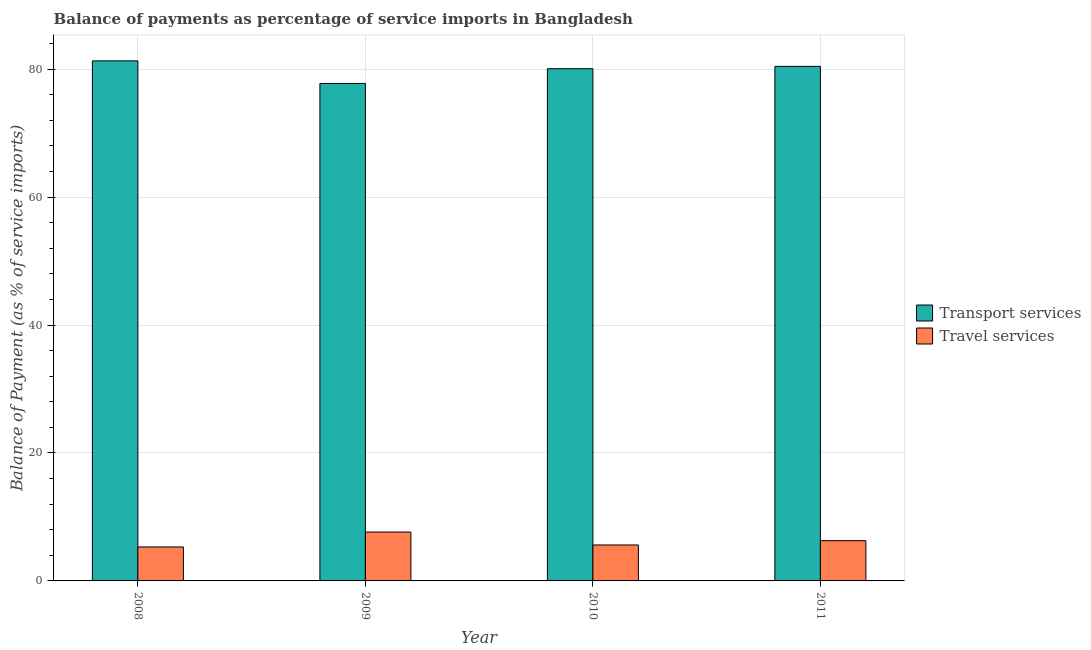How many groups of bars are there?
Your answer should be very brief. 4. Are the number of bars on each tick of the X-axis equal?
Offer a terse response. Yes. How many bars are there on the 2nd tick from the left?
Your answer should be compact. 2. In how many cases, is the number of bars for a given year not equal to the number of legend labels?
Offer a terse response. 0. What is the balance of payments of transport services in 2011?
Offer a very short reply. 80.43. Across all years, what is the maximum balance of payments of transport services?
Ensure brevity in your answer.  81.29. Across all years, what is the minimum balance of payments of travel services?
Offer a very short reply. 5.31. What is the total balance of payments of travel services in the graph?
Offer a very short reply. 24.86. What is the difference between the balance of payments of travel services in 2009 and that in 2010?
Keep it short and to the point. 2.02. What is the difference between the balance of payments of travel services in 2008 and the balance of payments of transport services in 2010?
Provide a short and direct response. -0.31. What is the average balance of payments of travel services per year?
Your answer should be very brief. 6.22. In how many years, is the balance of payments of transport services greater than 48 %?
Give a very brief answer. 4. What is the ratio of the balance of payments of transport services in 2008 to that in 2011?
Your response must be concise. 1.01. Is the balance of payments of transport services in 2010 less than that in 2011?
Provide a succinct answer. Yes. Is the difference between the balance of payments of transport services in 2008 and 2009 greater than the difference between the balance of payments of travel services in 2008 and 2009?
Ensure brevity in your answer.  No. What is the difference between the highest and the second highest balance of payments of travel services?
Make the answer very short. 1.34. What is the difference between the highest and the lowest balance of payments of travel services?
Make the answer very short. 2.33. In how many years, is the balance of payments of travel services greater than the average balance of payments of travel services taken over all years?
Your answer should be very brief. 2. Is the sum of the balance of payments of travel services in 2010 and 2011 greater than the maximum balance of payments of transport services across all years?
Make the answer very short. Yes. What does the 1st bar from the left in 2008 represents?
Your answer should be very brief. Transport services. What does the 1st bar from the right in 2010 represents?
Offer a terse response. Travel services. How many bars are there?
Offer a very short reply. 8. Are the values on the major ticks of Y-axis written in scientific E-notation?
Ensure brevity in your answer.  No. What is the title of the graph?
Offer a terse response. Balance of payments as percentage of service imports in Bangladesh. What is the label or title of the Y-axis?
Give a very brief answer. Balance of Payment (as % of service imports). What is the Balance of Payment (as % of service imports) of Transport services in 2008?
Provide a succinct answer. 81.29. What is the Balance of Payment (as % of service imports) of Travel services in 2008?
Provide a short and direct response. 5.31. What is the Balance of Payment (as % of service imports) in Transport services in 2009?
Your answer should be compact. 77.76. What is the Balance of Payment (as % of service imports) of Travel services in 2009?
Keep it short and to the point. 7.64. What is the Balance of Payment (as % of service imports) of Transport services in 2010?
Ensure brevity in your answer.  80.06. What is the Balance of Payment (as % of service imports) in Travel services in 2010?
Offer a very short reply. 5.62. What is the Balance of Payment (as % of service imports) in Transport services in 2011?
Offer a very short reply. 80.43. What is the Balance of Payment (as % of service imports) in Travel services in 2011?
Provide a succinct answer. 6.29. Across all years, what is the maximum Balance of Payment (as % of service imports) in Transport services?
Offer a terse response. 81.29. Across all years, what is the maximum Balance of Payment (as % of service imports) in Travel services?
Offer a terse response. 7.64. Across all years, what is the minimum Balance of Payment (as % of service imports) of Transport services?
Your answer should be compact. 77.76. Across all years, what is the minimum Balance of Payment (as % of service imports) in Travel services?
Make the answer very short. 5.31. What is the total Balance of Payment (as % of service imports) in Transport services in the graph?
Your answer should be very brief. 319.53. What is the total Balance of Payment (as % of service imports) in Travel services in the graph?
Offer a terse response. 24.86. What is the difference between the Balance of Payment (as % of service imports) of Transport services in 2008 and that in 2009?
Offer a very short reply. 3.53. What is the difference between the Balance of Payment (as % of service imports) of Travel services in 2008 and that in 2009?
Keep it short and to the point. -2.33. What is the difference between the Balance of Payment (as % of service imports) of Transport services in 2008 and that in 2010?
Make the answer very short. 1.22. What is the difference between the Balance of Payment (as % of service imports) in Travel services in 2008 and that in 2010?
Offer a very short reply. -0.31. What is the difference between the Balance of Payment (as % of service imports) in Transport services in 2008 and that in 2011?
Provide a succinct answer. 0.86. What is the difference between the Balance of Payment (as % of service imports) of Travel services in 2008 and that in 2011?
Your response must be concise. -0.98. What is the difference between the Balance of Payment (as % of service imports) in Transport services in 2009 and that in 2010?
Your response must be concise. -2.3. What is the difference between the Balance of Payment (as % of service imports) of Travel services in 2009 and that in 2010?
Make the answer very short. 2.02. What is the difference between the Balance of Payment (as % of service imports) of Transport services in 2009 and that in 2011?
Your response must be concise. -2.67. What is the difference between the Balance of Payment (as % of service imports) in Travel services in 2009 and that in 2011?
Ensure brevity in your answer.  1.34. What is the difference between the Balance of Payment (as % of service imports) of Transport services in 2010 and that in 2011?
Make the answer very short. -0.37. What is the difference between the Balance of Payment (as % of service imports) of Travel services in 2010 and that in 2011?
Give a very brief answer. -0.67. What is the difference between the Balance of Payment (as % of service imports) in Transport services in 2008 and the Balance of Payment (as % of service imports) in Travel services in 2009?
Provide a succinct answer. 73.65. What is the difference between the Balance of Payment (as % of service imports) of Transport services in 2008 and the Balance of Payment (as % of service imports) of Travel services in 2010?
Offer a terse response. 75.67. What is the difference between the Balance of Payment (as % of service imports) of Transport services in 2008 and the Balance of Payment (as % of service imports) of Travel services in 2011?
Provide a short and direct response. 74.99. What is the difference between the Balance of Payment (as % of service imports) in Transport services in 2009 and the Balance of Payment (as % of service imports) in Travel services in 2010?
Provide a short and direct response. 72.14. What is the difference between the Balance of Payment (as % of service imports) of Transport services in 2009 and the Balance of Payment (as % of service imports) of Travel services in 2011?
Make the answer very short. 71.47. What is the difference between the Balance of Payment (as % of service imports) of Transport services in 2010 and the Balance of Payment (as % of service imports) of Travel services in 2011?
Your answer should be very brief. 73.77. What is the average Balance of Payment (as % of service imports) of Transport services per year?
Your answer should be compact. 79.88. What is the average Balance of Payment (as % of service imports) of Travel services per year?
Make the answer very short. 6.22. In the year 2008, what is the difference between the Balance of Payment (as % of service imports) in Transport services and Balance of Payment (as % of service imports) in Travel services?
Give a very brief answer. 75.97. In the year 2009, what is the difference between the Balance of Payment (as % of service imports) of Transport services and Balance of Payment (as % of service imports) of Travel services?
Your response must be concise. 70.12. In the year 2010, what is the difference between the Balance of Payment (as % of service imports) of Transport services and Balance of Payment (as % of service imports) of Travel services?
Provide a short and direct response. 74.44. In the year 2011, what is the difference between the Balance of Payment (as % of service imports) in Transport services and Balance of Payment (as % of service imports) in Travel services?
Ensure brevity in your answer.  74.14. What is the ratio of the Balance of Payment (as % of service imports) in Transport services in 2008 to that in 2009?
Give a very brief answer. 1.05. What is the ratio of the Balance of Payment (as % of service imports) of Travel services in 2008 to that in 2009?
Provide a succinct answer. 0.7. What is the ratio of the Balance of Payment (as % of service imports) of Transport services in 2008 to that in 2010?
Give a very brief answer. 1.02. What is the ratio of the Balance of Payment (as % of service imports) in Travel services in 2008 to that in 2010?
Keep it short and to the point. 0.95. What is the ratio of the Balance of Payment (as % of service imports) of Transport services in 2008 to that in 2011?
Give a very brief answer. 1.01. What is the ratio of the Balance of Payment (as % of service imports) of Travel services in 2008 to that in 2011?
Your response must be concise. 0.84. What is the ratio of the Balance of Payment (as % of service imports) in Transport services in 2009 to that in 2010?
Your answer should be very brief. 0.97. What is the ratio of the Balance of Payment (as % of service imports) of Travel services in 2009 to that in 2010?
Offer a terse response. 1.36. What is the ratio of the Balance of Payment (as % of service imports) of Transport services in 2009 to that in 2011?
Ensure brevity in your answer.  0.97. What is the ratio of the Balance of Payment (as % of service imports) in Travel services in 2009 to that in 2011?
Offer a very short reply. 1.21. What is the ratio of the Balance of Payment (as % of service imports) of Transport services in 2010 to that in 2011?
Ensure brevity in your answer.  1. What is the ratio of the Balance of Payment (as % of service imports) of Travel services in 2010 to that in 2011?
Make the answer very short. 0.89. What is the difference between the highest and the second highest Balance of Payment (as % of service imports) of Transport services?
Keep it short and to the point. 0.86. What is the difference between the highest and the second highest Balance of Payment (as % of service imports) in Travel services?
Provide a short and direct response. 1.34. What is the difference between the highest and the lowest Balance of Payment (as % of service imports) in Transport services?
Your response must be concise. 3.53. What is the difference between the highest and the lowest Balance of Payment (as % of service imports) in Travel services?
Your answer should be compact. 2.33. 